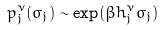Convert formula to latex. <formula><loc_0><loc_0><loc_500><loc_500>p _ { j } ^ { \nu } ( \sigma _ { j } ) \sim \exp ( \beta h _ { j } ^ { \nu } \sigma _ { j } )</formula> 